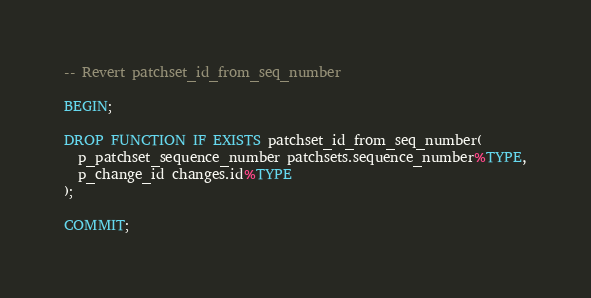Convert code to text. <code><loc_0><loc_0><loc_500><loc_500><_SQL_>-- Revert patchset_id_from_seq_number

BEGIN;

DROP FUNCTION IF EXISTS patchset_id_from_seq_number(
  p_patchset_sequence_number patchsets.sequence_number%TYPE,
  p_change_id changes.id%TYPE
);

COMMIT;
</code> 